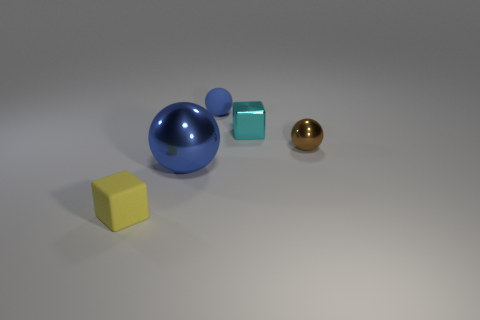Subtract all blue blocks. How many blue spheres are left? 2 Subtract all metal balls. How many balls are left? 1 Add 1 matte objects. How many objects exist? 6 Subtract all spheres. How many objects are left? 2 Subtract all big red rubber balls. Subtract all rubber objects. How many objects are left? 3 Add 1 tiny yellow matte objects. How many tiny yellow matte objects are left? 2 Add 5 tiny yellow matte things. How many tiny yellow matte things exist? 6 Subtract 0 purple spheres. How many objects are left? 5 